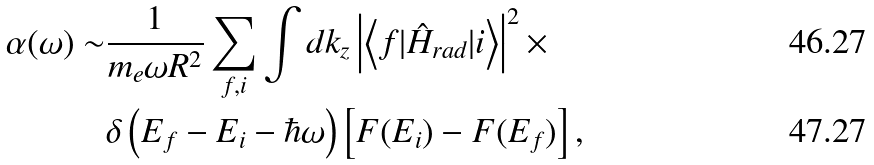Convert formula to latex. <formula><loc_0><loc_0><loc_500><loc_500>\alpha ( \omega ) \sim & \frac { 1 } { m _ { e } \omega R ^ { 2 } } \sum _ { f , i } \int d k _ { z } \left | \left < f | \hat { H } _ { r a d } | i \right > \right | ^ { 2 } \times \\ & \delta \left ( E _ { f } - E _ { i } - \hbar { \omega } \right ) \left [ F ( E _ { i } ) - F ( E _ { f } ) \right ] ,</formula> 